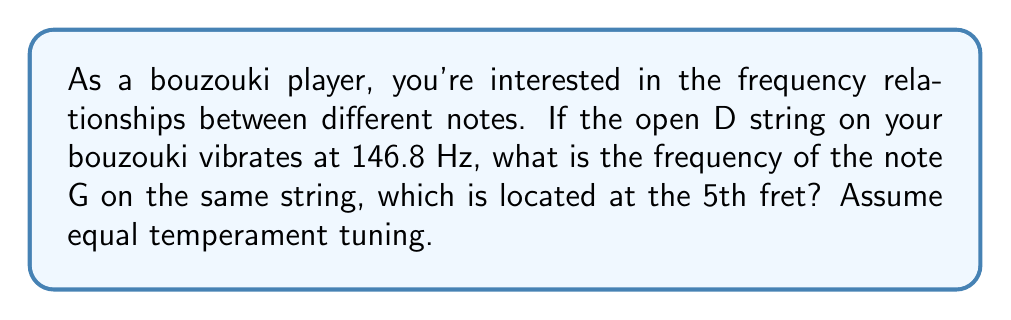Could you help me with this problem? To solve this problem, we need to understand the relationship between notes in equal temperament tuning and how frequency ratios work on fretted instruments.

1. In equal temperament, each semitone has a frequency ratio of $\sqrt[12]{2}$ (the twelfth root of 2).

2. The interval from D to G is a perfect fourth, which consists of 5 semitones.

3. To calculate the frequency ratio, we raise $\sqrt[12]{2}$ to the power of 5:

   $(\sqrt[12]{2})^5 = 2^{\frac{5}{12}} \approx 1.3348398541700344$

4. To find the frequency of G, we multiply the frequency of D by this ratio:

   $f_G = f_D \times 2^{\frac{5}{12}}$

5. Substituting the given frequency for D:

   $f_G = 146.8 \text{ Hz} \times 2^{\frac{5}{12}}$

6. Calculate the result:

   $f_G = 146.8 \text{ Hz} \times 1.3348398541700344 \approx 195.9985 \text{ Hz}$

Therefore, the frequency of the note G on the 5th fret of the D string is approximately 195.9985 Hz.
Answer: $f_G \approx 195.9985 \text{ Hz}$ 